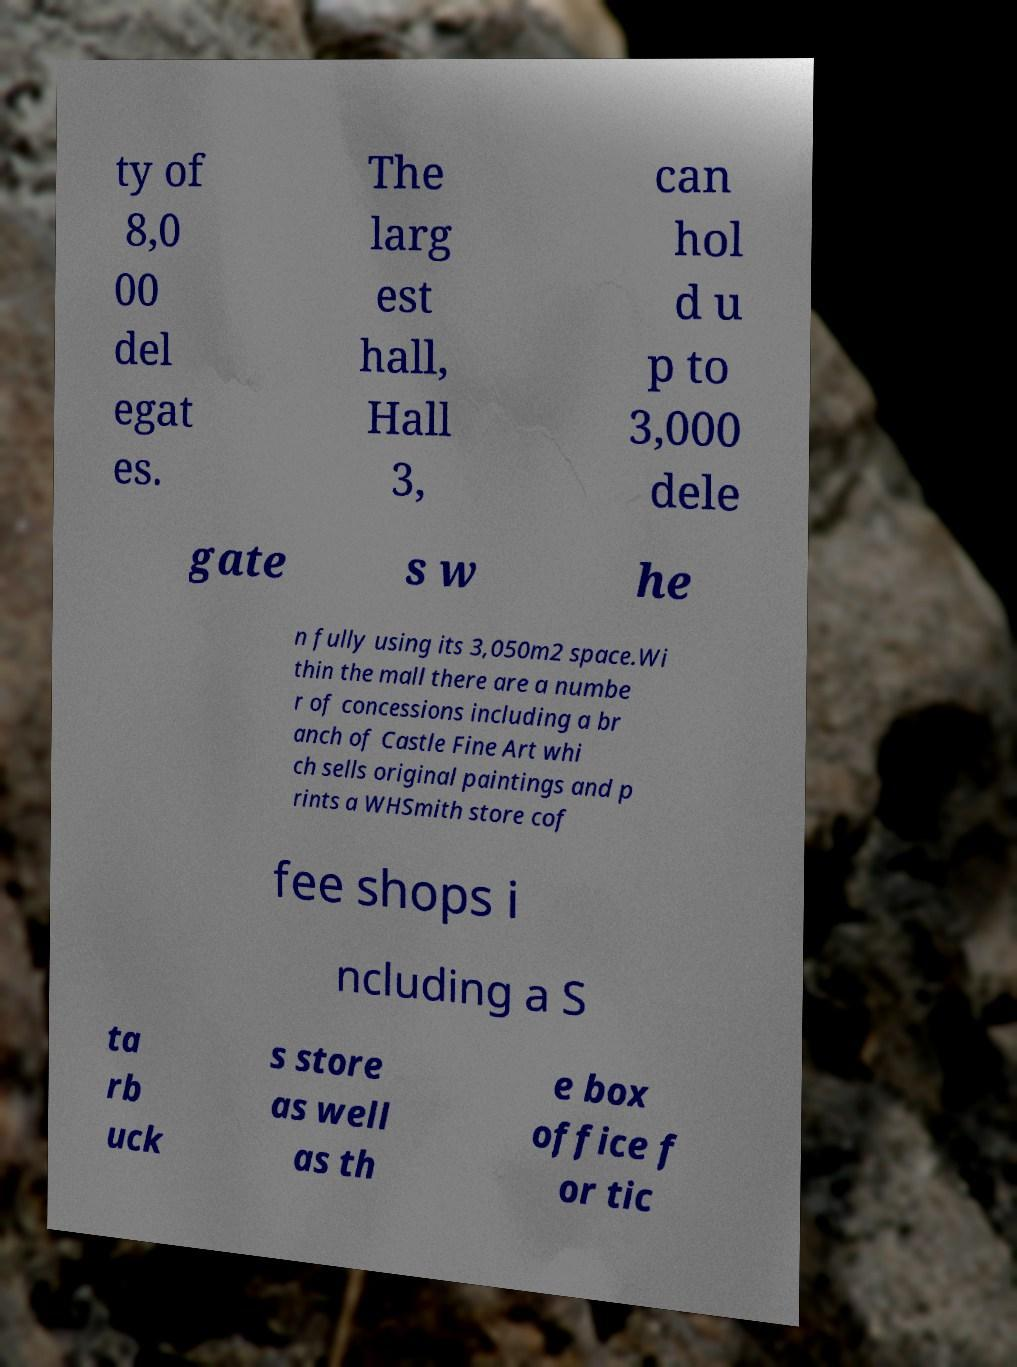Can you read and provide the text displayed in the image?This photo seems to have some interesting text. Can you extract and type it out for me? ty of 8,0 00 del egat es. The larg est hall, Hall 3, can hol d u p to 3,000 dele gate s w he n fully using its 3,050m2 space.Wi thin the mall there are a numbe r of concessions including a br anch of Castle Fine Art whi ch sells original paintings and p rints a WHSmith store cof fee shops i ncluding a S ta rb uck s store as well as th e box office f or tic 